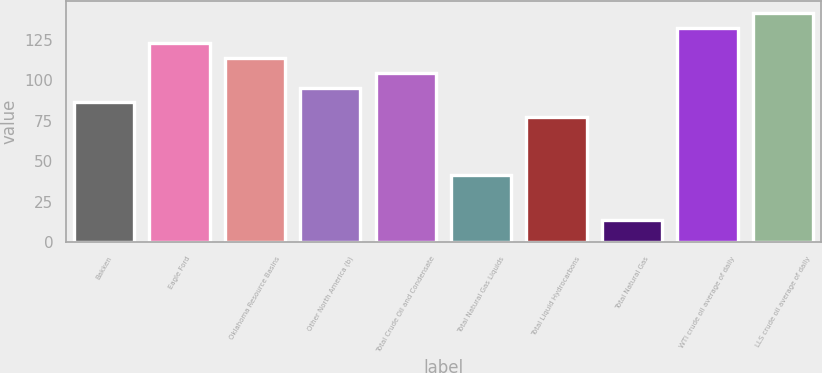Convert chart. <chart><loc_0><loc_0><loc_500><loc_500><bar_chart><fcel>Bakken<fcel>Eagle Ford<fcel>Oklahoma Resource Basins<fcel>Other North America (b)<fcel>Total Crude Oil and Condensate<fcel>Total Natural Gas Liquids<fcel>Total Liquid Hydrocarbons<fcel>Total Natural Gas<fcel>WTI crude oil average of daily<fcel>LLS crude oil average of daily<nl><fcel>86.24<fcel>123.12<fcel>113.9<fcel>95.46<fcel>104.68<fcel>41.74<fcel>77.02<fcel>13.64<fcel>132.34<fcel>141.56<nl></chart> 